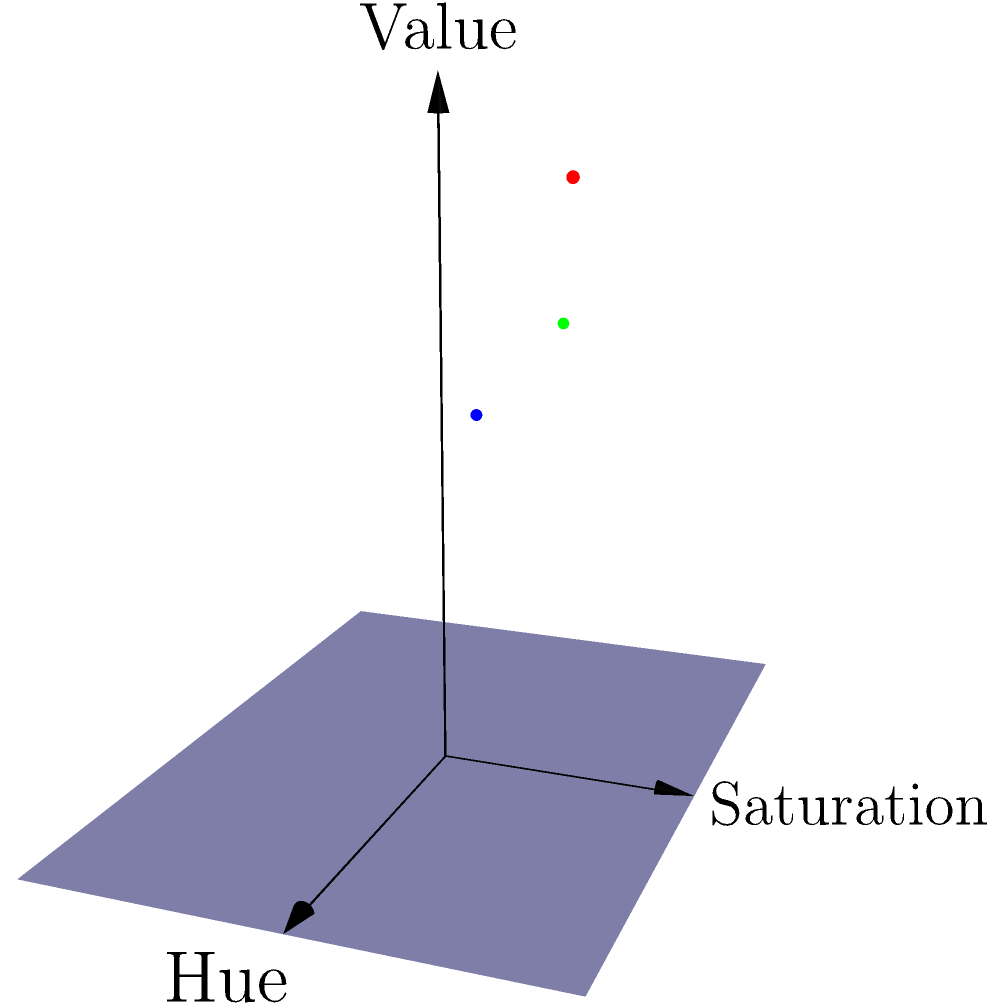In the 3D color space coordinate system shown above, three different lipstick shades are represented by colored dots. If you were to create a new bridal lipstick shade by mixing equal parts of these three colors, what would be the approximate coordinates $(h, s, v)$ of the resulting color in this HSV (Hue, Saturation, Value) space? To find the coordinates of the new lipstick shade, we need to follow these steps:

1. Identify the coordinates of each lipstick shade:
   Red dot: $(0.7, 0.8, 0.9)$
   Green dot: $(0.3, 0.6, 0.7)$
   Blue dot: $(0.5, 0.4, 0.6)$

2. Since we're mixing equal parts of each color, we need to calculate the average of each coordinate:

   Hue (h): $\frac{0.7 + 0.3 + 0.5}{3} = \frac{1.5}{3} = 0.5$

   Saturation (s): $\frac{0.8 + 0.6 + 0.4}{3} = \frac{1.8}{3} = 0.6$

   Value (v): $\frac{0.9 + 0.7 + 0.6}{3} = \frac{2.2}{3} \approx 0.73$

3. Round the results to one decimal place for simplicity.

Therefore, the approximate coordinates of the new bridal lipstick shade in the HSV color space would be $(0.5, 0.6, 0.7)$.
Answer: $(0.5, 0.6, 0.7)$ 